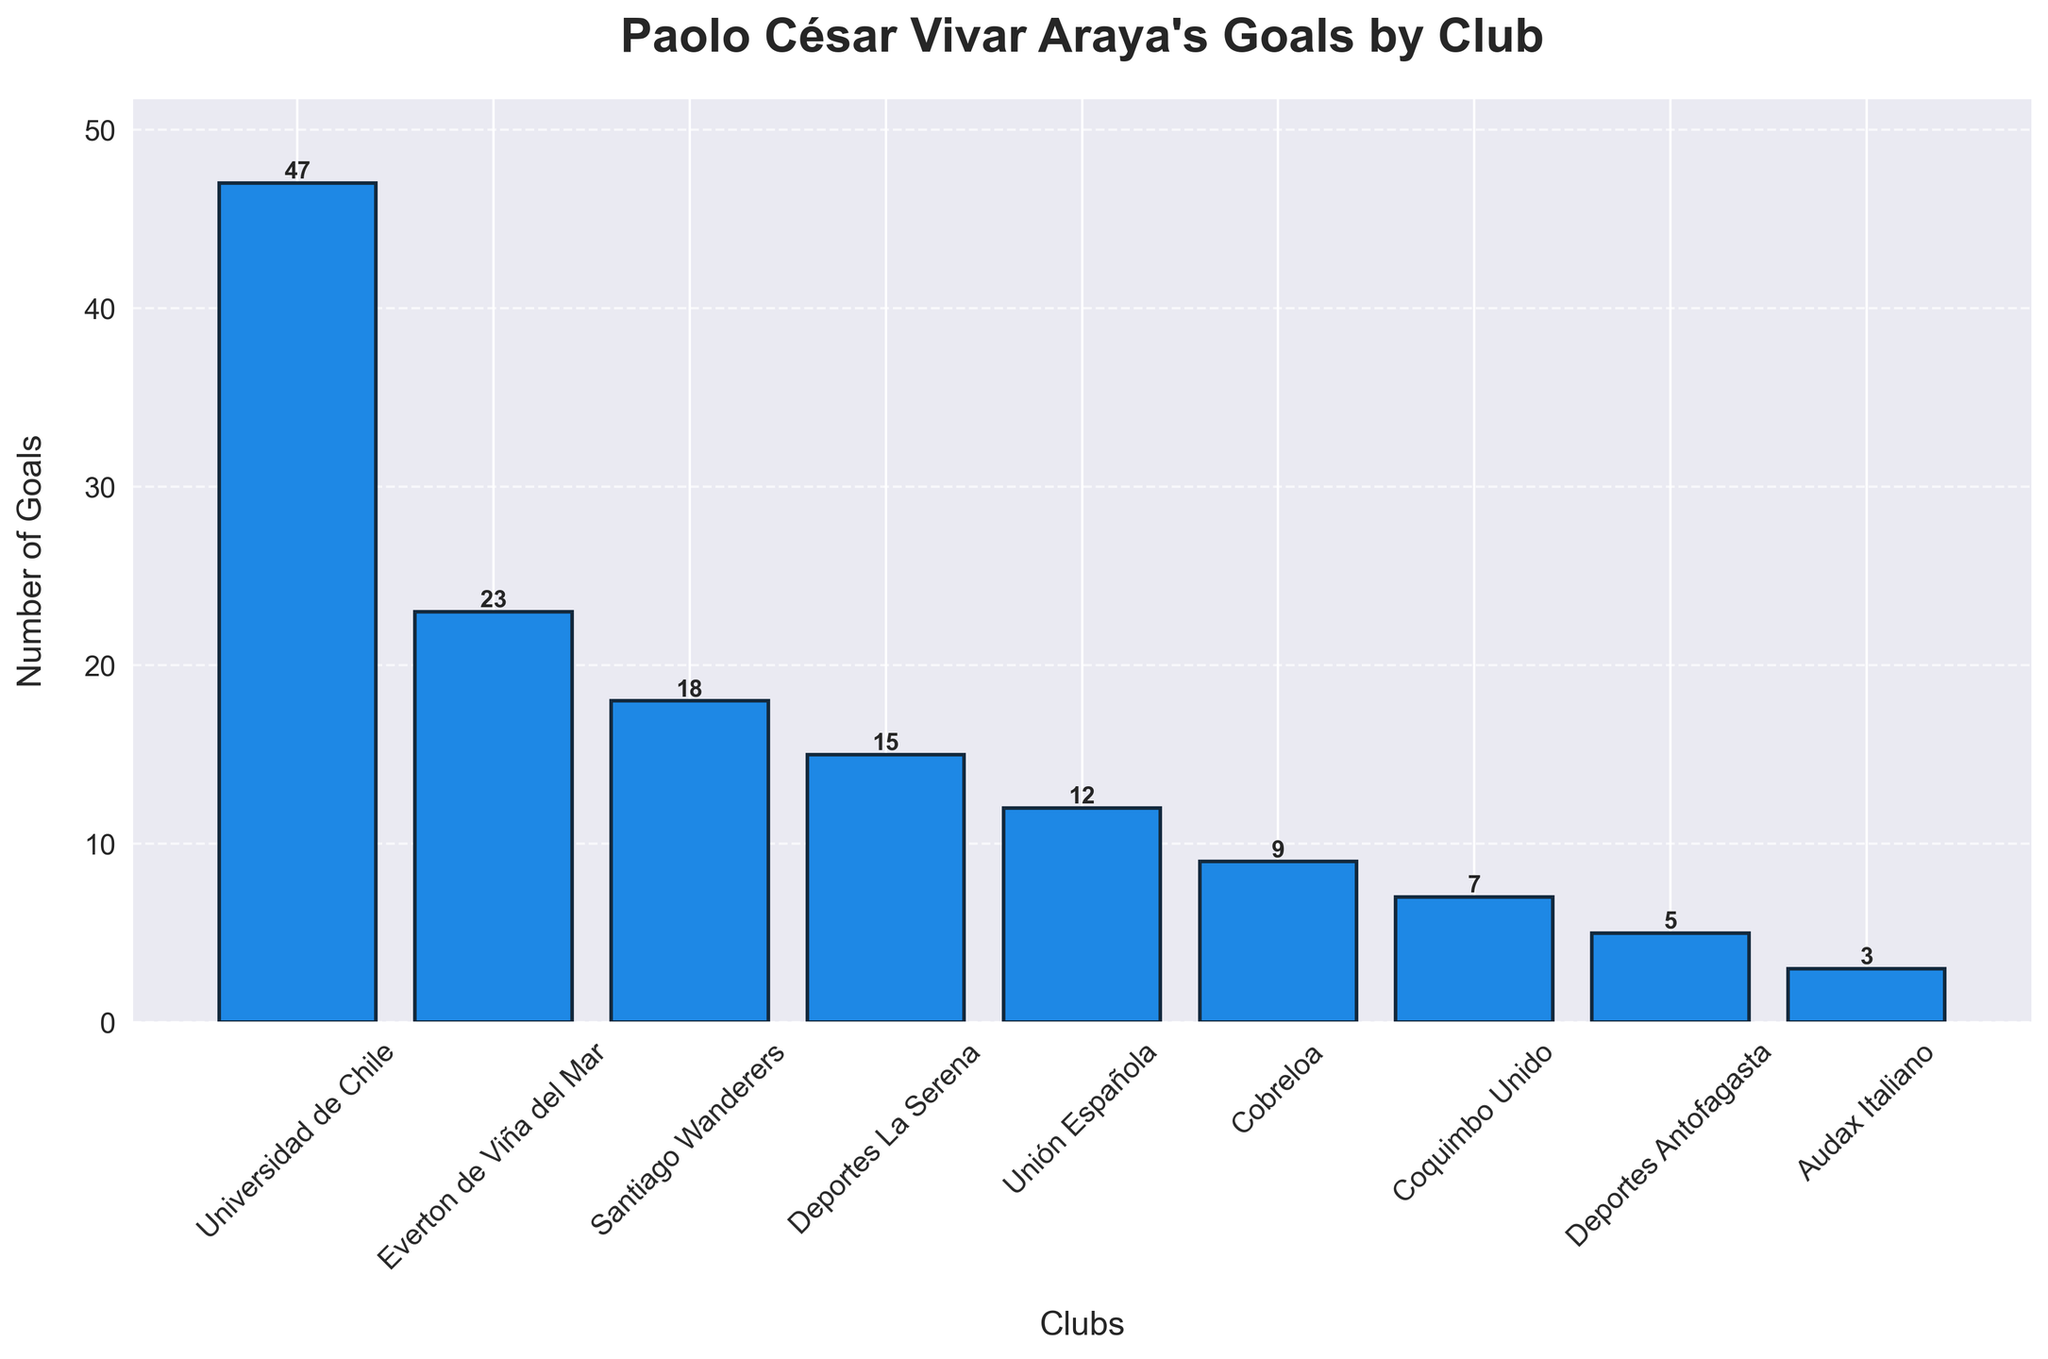Which club did Paolo César Vivar Araya score the most goals for? The tallest bar in the chart represents the club where Paolo César Vivar Araya scored the most goals. This club is Universidad de Chile with 47 goals.
Answer: Universidad de Chile How many goals did Paolo César Vivar Araya score for Universidad de Chile and Everton de Viña del Mar combined? First, find the goals for both clubs from the chart (Universidad de Chile: 47, Everton de Viña del Mar: 23). Add these two numbers together (47 + 23 = 70).
Answer: 70 Did Paolo César Vivar Araya score more goals for Unión Española or Cobreloa? Compare the bars representing Unión Española and Cobreloa. The bar for Unión Española (12 goals) is taller than the bar for Cobreloa (9 goals).
Answer: Unión Española What is the difference in the number of goals between Santiago Wanderers and Deportes La Serena? Find the goals for both clubs from the chart (Santiago Wanderers: 18, Deportes La Serena: 15). Subtract the number for Deportes La Serena from that for Santiago Wanderers (18 - 15 = 3).
Answer: 3 Which club did Paolo César Vivar Araya score the least goals for? Look for the shortest bar in the chart. This bar represents Audax Italiano, with 3 goals scored.
Answer: Audax Italiano How many clubs did Paolo César Vivar Araya score more than 10 goals for? Count the number of bars with a height representing more than 10 goals. The clubs are Universidad de Chile, Everton de Viña del Mar, Santiago Wanderers, Deportes La Serena, and Unión Española (5 clubs).
Answer: 5 What is the average number of goals Paolo César Vivar Araya scored for the clubs listed? First, sum the total number of goals (47 + 23 + 18 + 15 + 12 + 9 + 7 + 5 + 3 = 139). Then, divide by the total number of clubs (139 / 9 = 15.44).
Answer: 15.44 By how many goals does the number of goals for Universidad de Chile surpass those for Coquimbo Unido? Subtract the number of goals of Coquimbo Unido from Universidad de Chile (47 - 7 = 40).
Answer: 40 Rank the clubs in descending order of the number of goals scored for each by Paolo César Vivar Araya. Observe the height of the bars and list the clubs from the tallest bar to the shortest: Universidad de Chile (47), Everton de Viña del Mar (23), Santiago Wanderers (18), Deportes La Serena (15), Unión Española (12), Cobreloa (9), Coquimbo Unido (7), Deportes Antofagasta (5), Audax Italiano (3).
Answer: Universidad de Chile, Everton de Viña del Mar, Santiago Wanderers, Deportes La Serena, Unión Española, Cobreloa, Coquimbo Unido, Deportes Antofagasta, Audax Italiano What is the total number of goals scored for clubs with fewer than 10 goals each? Identify the clubs: Cobreloa (9), Coquimbo Unido (7), Deportes Antofagasta (5), Audax Italiano (3). Sum the goals (9 + 7 + 5 + 3 = 24).
Answer: 24 